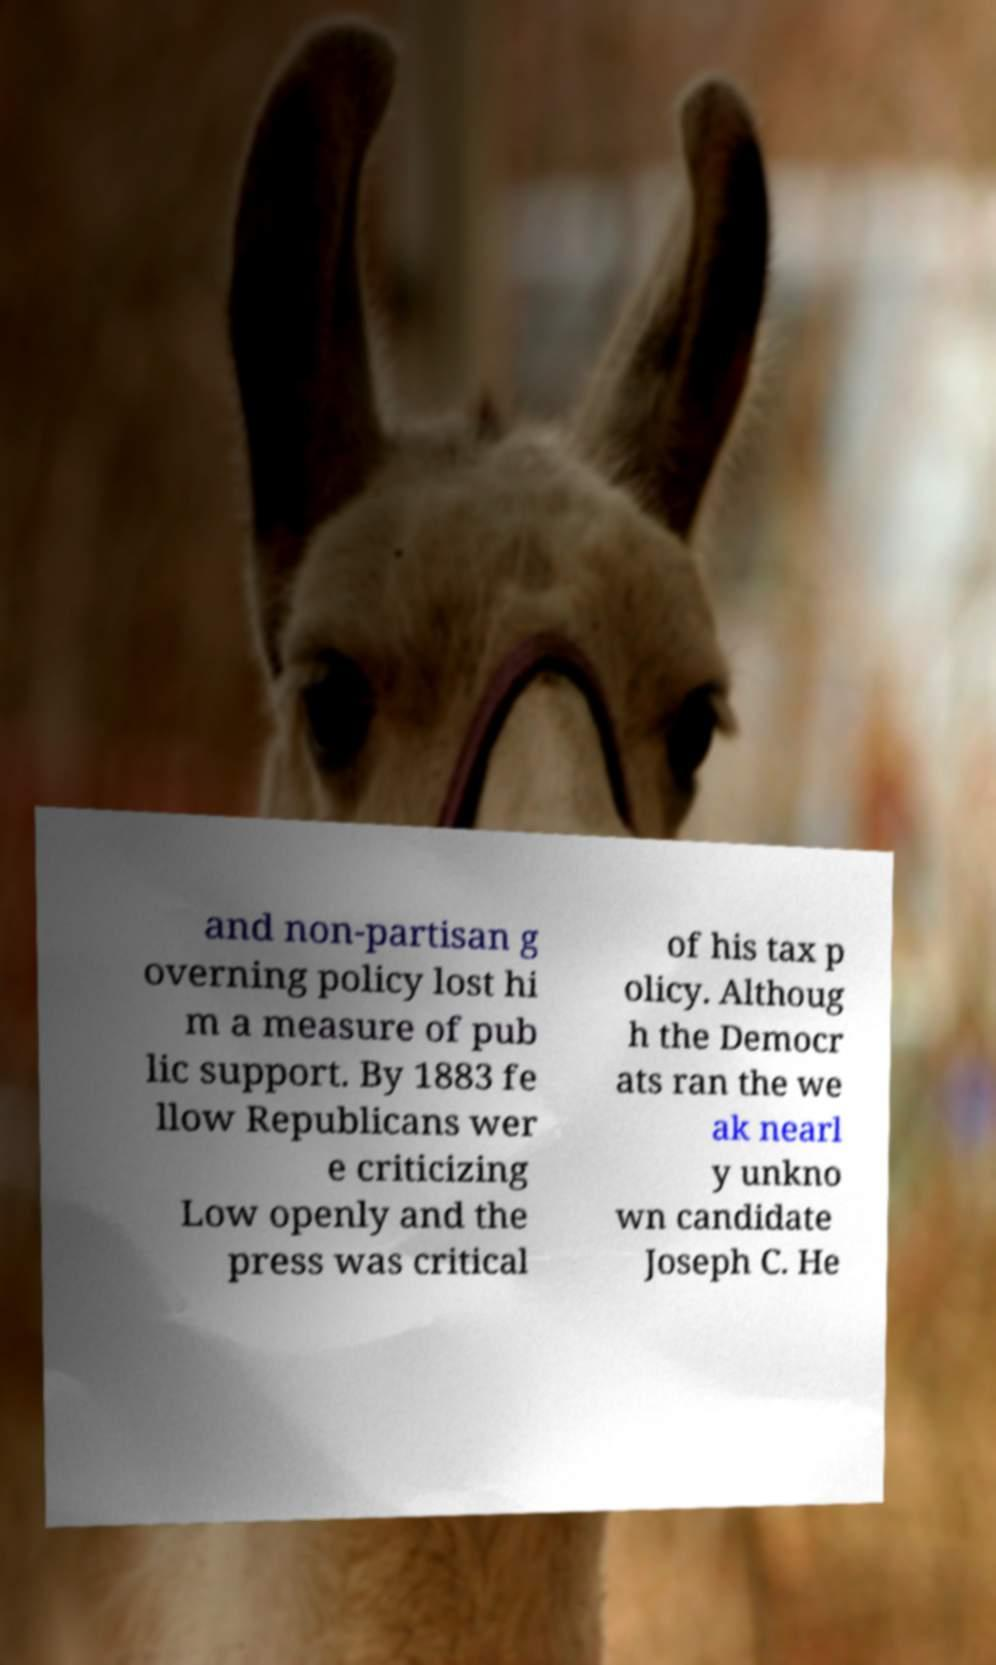Could you assist in decoding the text presented in this image and type it out clearly? and non-partisan g overning policy lost hi m a measure of pub lic support. By 1883 fe llow Republicans wer e criticizing Low openly and the press was critical of his tax p olicy. Althoug h the Democr ats ran the we ak nearl y unkno wn candidate Joseph C. He 